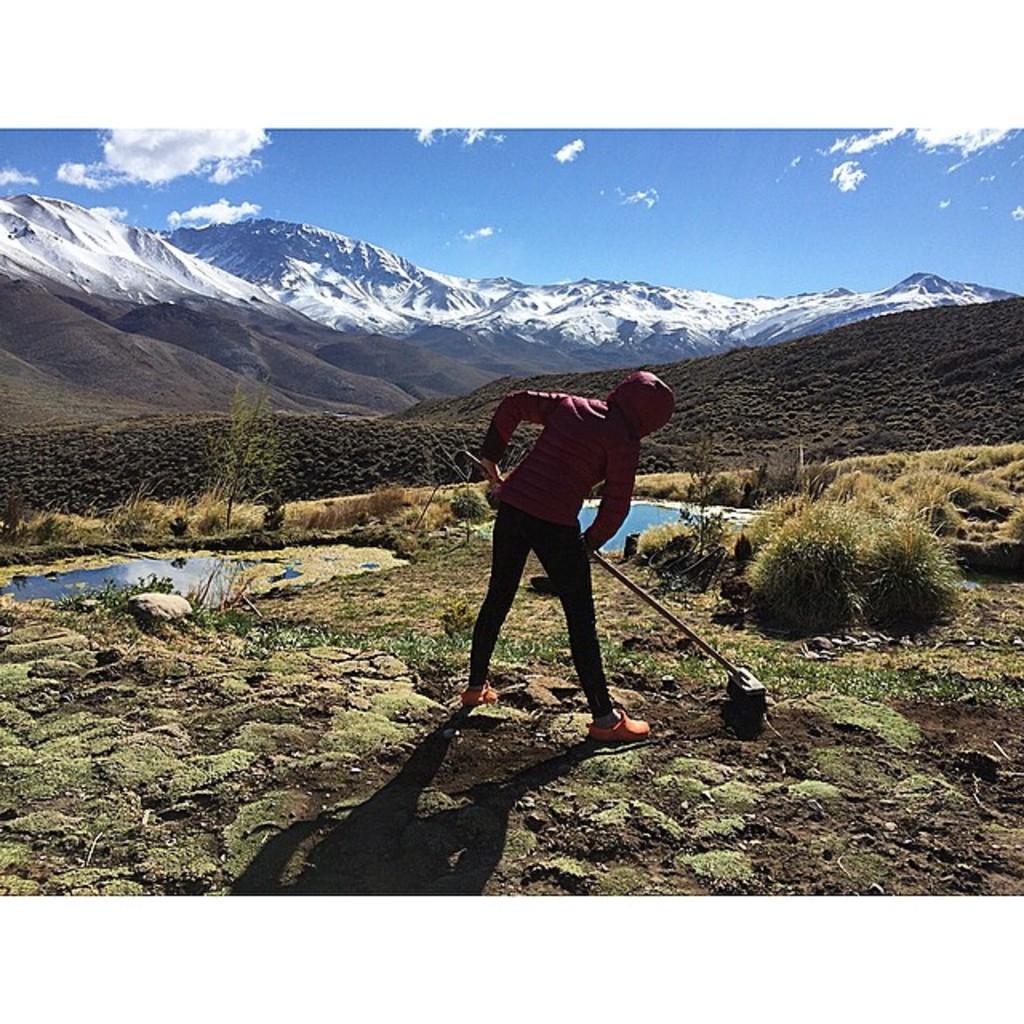Can you describe this image briefly? Here we can see a woman standing on the ground by holding an object in her hand and there is a small pond with water in it. In the background there are mountains,snow mountains and clouds in the sky. 